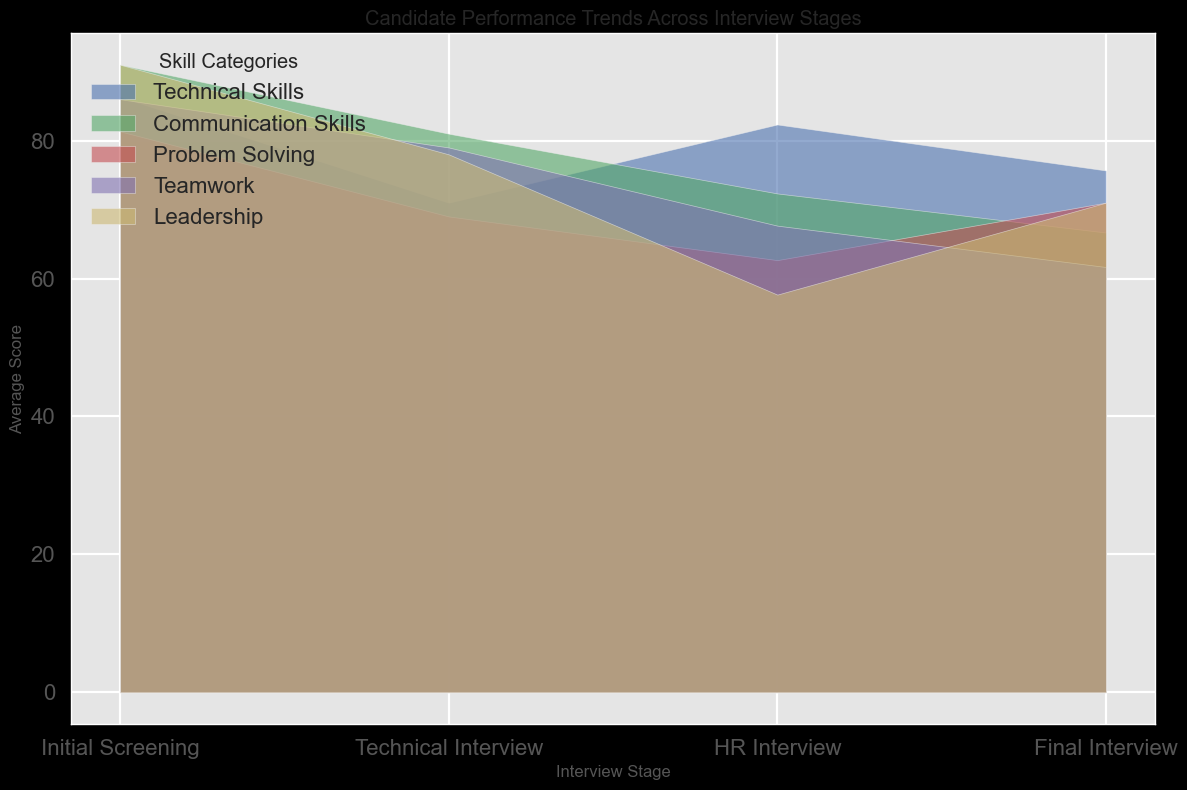What's the average score of Technical Skills in the Initial Screening stage? To find the average score of Technical Skills in the Initial Screening stage, sum the individual scores (80, 85, 82) and divide by the number of scores. (80 + 85 + 82) / 3 = 247 / 3 = 82.33
Answer: 82.33 Which skill category shows the greatest improvement from the Initial Screening stage to the Final Interview stage? Look at the difference in average scores for each skill category between the Initial Screening and Final Interview stages. Technical Skills went from 82.33 to 86.33 (difference of 4). Communication Skills went from 72.33 to 91 (difference of 18.67). Problem Solving went from 62.67 to 81.33 (difference of 18.66). Teamwork went from 67.67 to 86 (difference of 18.33). Leadership went from 57.67 to 91 (difference of 33.33).
Answer: Leadership How does the average score of Teamwork change from the Initial Screening stage to the Technical Interview stage? To find this, calculate the average score for Teamwork in each stage and then find the difference. Initial Screening: (65 + 70 + 68) / 3 = 67.67. Technical Interview: (60 + 63 + 62) / 3 = 61.67. Change: 61.67 - 67.67 = -6
Answer: Decreases by 6 Which skill category has the highest score in the HR Interview stage? Refer to the HR Interview stage and identify the highest average score among the skill categories. Technical Skills: 71, Communication Skills: 81, Problem Solving: 69, Teamwork: 79, Leadership: 78. The highest value is in Communication Skills (81).
Answer: Communication Skills What is the trend of Problem Solving skills from Initial Screening to Final Interview? Examine the average scores for Problem Solving across the stages: Initial Screening (62.67), Technical Interview (71), HR Interview (69), Final Interview (81.33). The trend shows an initial increase, a slight decline at HR, then a significant increase at the Final Interview. Overall, the trend is upward.
Answer: Upward trend Compare the changes in average scores for Communication Skills and Leadership from Technical Interview to HR Interview. Which one improved more? For Communication Skills: Technical Interview avg is 66.67, HR Interview avg is 81. Change: 81 - 66.67 = 14.33. For Leadership: Technical Interview avg is 71.33, HR Interview avg is 78. Change: 78 - 71.33 = 6.67. Communication Skills improved by 14.33 while Leadership improved by 6.67.
Answer: Communication Skills improved more What is the average increase in Leadership scores per interview stage? Calculate the average Leadership score for each stage and find the increments per stage. Initial Screening: 57.67, Technical Interview: 71.33, HR Interview: 78, Final Interview: 91. Changes: (71.33 - 57.67) = 13.66, (78 - 71.33) = 6.67, (91 - 78) = 13. Average increase per stage = (13.66 + 6.67 + 13) / 3 = 11.11
Answer: 11.11 Which interview stage shows the least variance in scores across all skill categories? Calculate the variance for each skill category in every interview stage, then find the stage with the smallest overall average variance. Comparing variances: Initial Screening (81.63), Technical Interview (23.47), HR Interview (16.22), Final Interview (15.11). The final stage has the least variance.
Answer: Final Interview From the figure, which skill category has the most consistent performance across all stages? Consistent performance implies small changes in average scores across stages. Observing the skill categories' trajectories: Most skill categories show significant increases or fluctuations, but Problem Solving shows relatively small changes: Initial Screening (64), Technical Interview (71), HR Interview (69), Final Interview (81).
Answer: Problem Solving 